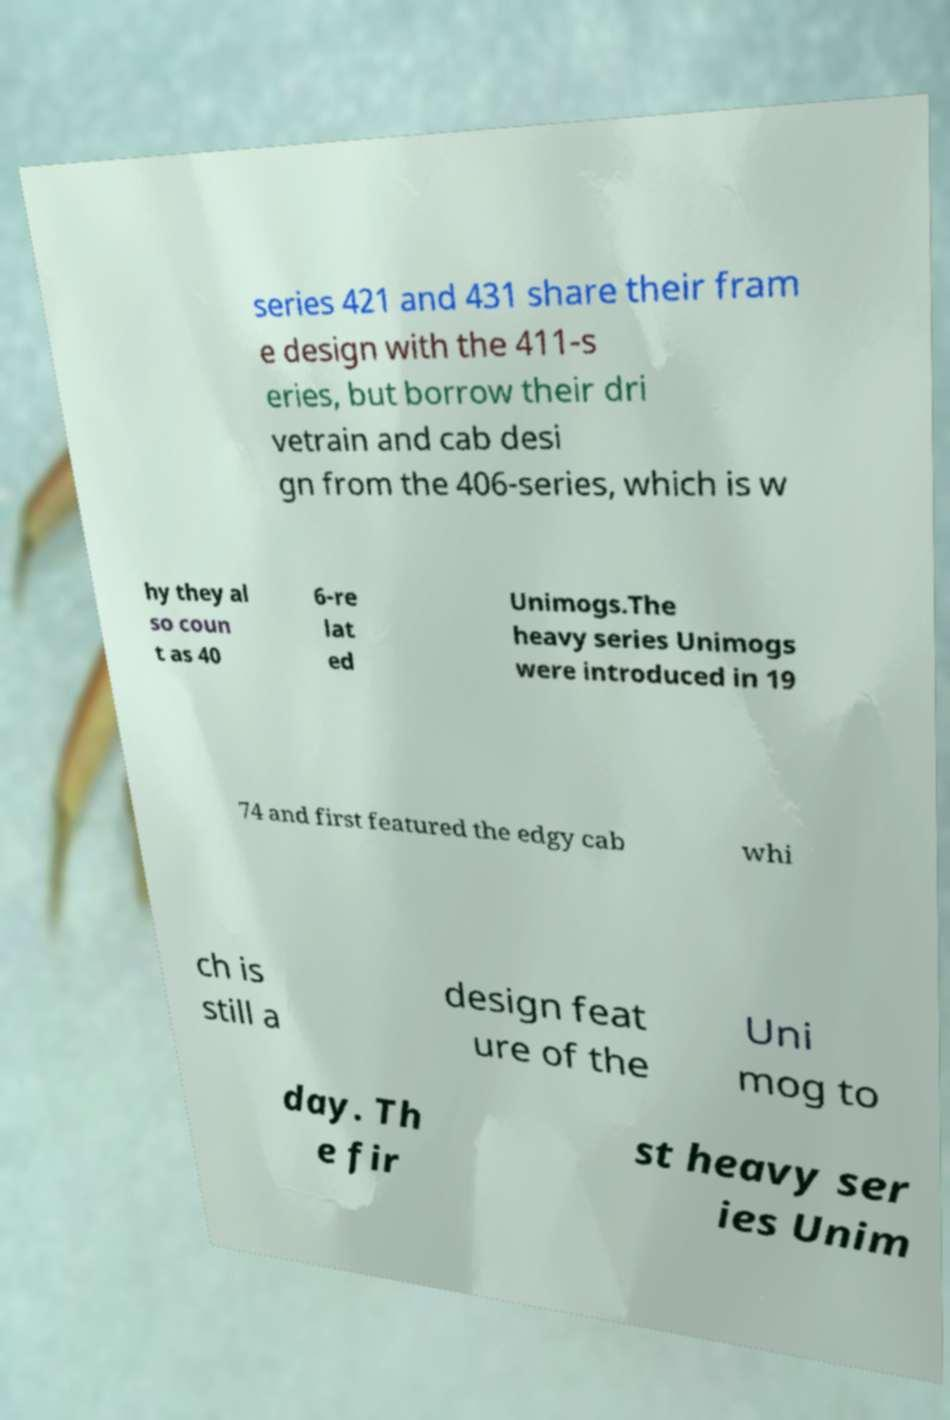Please read and relay the text visible in this image. What does it say? series 421 and 431 share their fram e design with the 411-s eries, but borrow their dri vetrain and cab desi gn from the 406-series, which is w hy they al so coun t as 40 6-re lat ed Unimogs.The heavy series Unimogs were introduced in 19 74 and first featured the edgy cab whi ch is still a design feat ure of the Uni mog to day. Th e fir st heavy ser ies Unim 